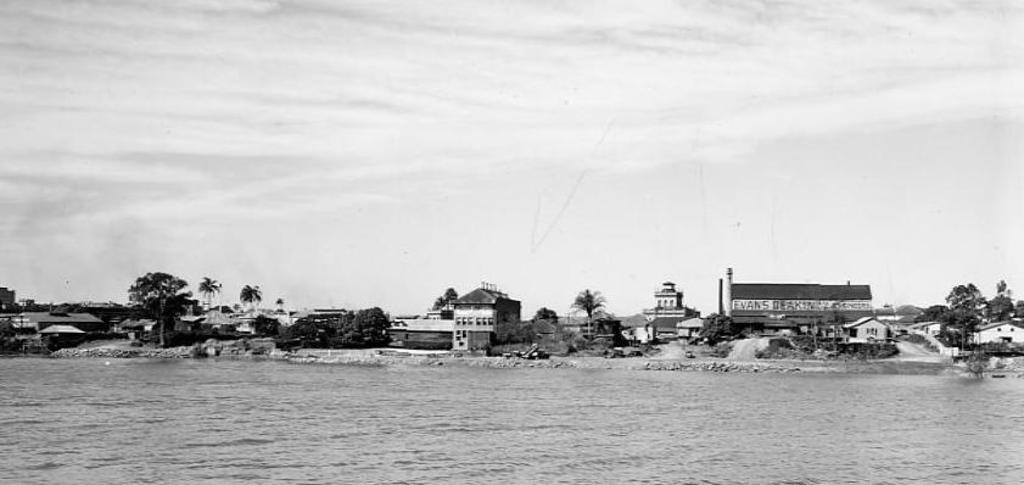What is located at the bottom of the image? There is a river at the bottom of the image. What can be seen in the background of the image? There are houses, trees, and sand in the background of the image. What is visible at the top of the image? The sky is visible at the top of the image. What type of net is being used to catch fish in the river? There is no net present in the image, and no fishing activity is depicted. 